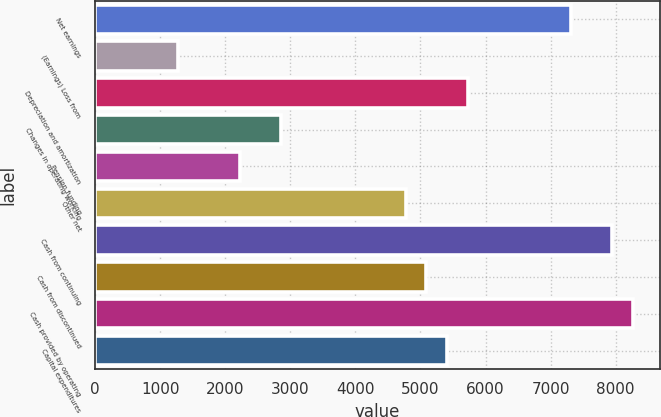Convert chart. <chart><loc_0><loc_0><loc_500><loc_500><bar_chart><fcel>Net earnings<fcel>(Earnings) Loss from<fcel>Depreciation and amortization<fcel>Changes in operating working<fcel>Pension funding<fcel>Other net<fcel>Cash from continuing<fcel>Cash from discontinued<fcel>Cash provided by operating<fcel>Capital expenditures<nl><fcel>7313.4<fcel>1275.2<fcel>5724.4<fcel>2864.2<fcel>2228.6<fcel>4771<fcel>7949<fcel>5088.8<fcel>8266.8<fcel>5406.6<nl></chart> 